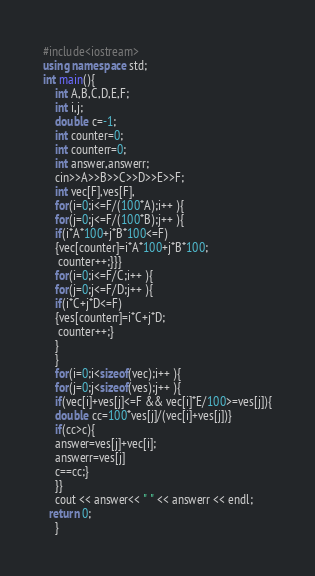<code> <loc_0><loc_0><loc_500><loc_500><_C++_>#include<iostream>
using namespace std;
int main(){
    int A,B,C,D,E,F;
    int i,j;
    double c=-1;
    int counter=0;
    int counterr=0;
    int answer,answerr;
    cin>>A>>B>>C>>D>>E>>F;
    int vec[F],ves[F],
    for(i=0;i<=F/(100*A);i++ ){
    for(j=0;j<=F/(100*B);j++ ){
    if(i*A*100+j*B*100<=F)
    {vec[counter]=i*A*100+j*B*100;
     counter++;}}}
    for(i=0;i<=F/C;i++ ){
    for(j=0;j<=F/D;j++ ){
    if(i*C+j*D<=F)
    {ves[counterr]=i*C+j*D;
     counter++;}
    }
    }
    for(i=0;i<sizeof(vec);i++ ){
    for(j=0;j<sizeof(ves);j++ ){
    if(vec[i]+ves[j]<=F && vec[i]*E/100>=ves[j]){
    double cc=100*ves[j]/(vec[i]+ves[j])}
    if(cc>c){
    answer=ves[j]+vec[i];
    answerr=ves[j]
    c==cc;}
    }}
    cout << answer<< " " << answerr << endl;
  return 0;
    }
</code> 